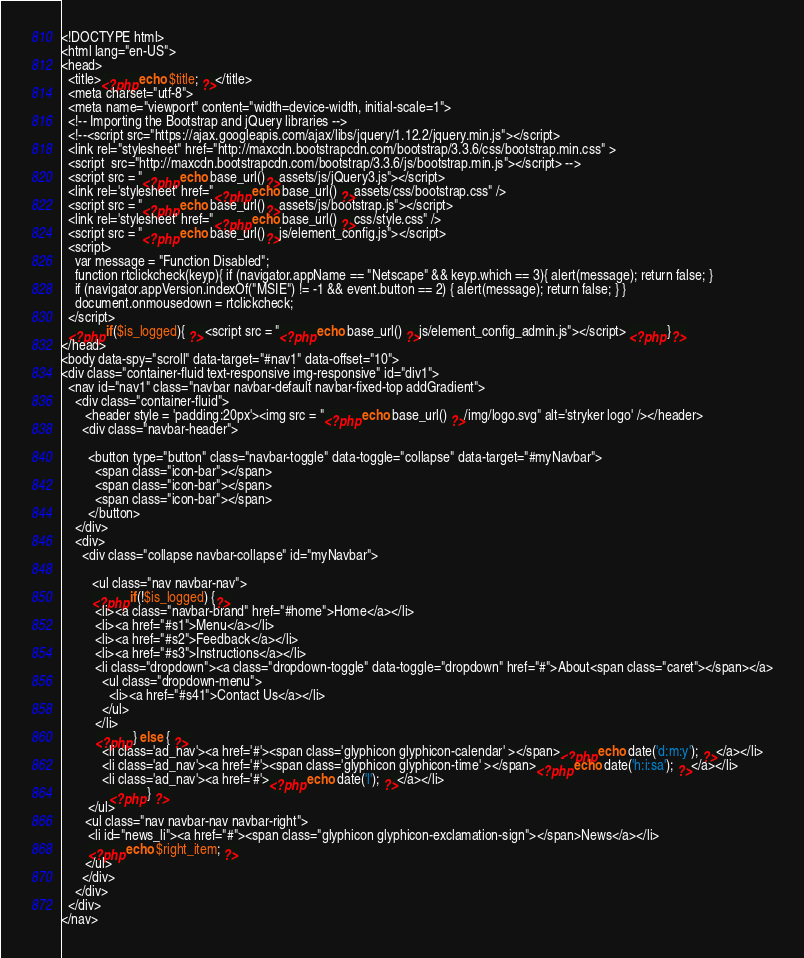Convert code to text. <code><loc_0><loc_0><loc_500><loc_500><_PHP_><!DOCTYPE html>
<html lang="en-US">
<head>
  <title><?php echo $title; ?></title>
  <meta charset="utf-8">
  <meta name="viewport" content="width=device-width, initial-scale=1">
  <!-- Importing the Bootstrap and jQuery libraries -->
  <!--<script src="https://ajax.googleapis.com/ajax/libs/jquery/1.12.2/jquery.min.js"></script>
  <link rel="stylesheet" href="http://maxcdn.bootstrapcdn.com/bootstrap/3.3.6/css/bootstrap.min.css" >
  <script  src="http://maxcdn.bootstrapcdn.com/bootstrap/3.3.6/js/bootstrap.min.js"></script> -->
  <script src = "<?php echo base_url()?>assets/js/jQuery3.js"></script> 
  <link rel='stylesheet' href="<?php echo base_url() ?>assets/css/bootstrap.css" />
  <script src = "<?php echo base_url()?>assets/js/bootstrap.js"></script> 
  <link rel='stylesheet' href="<?php echo base_url() ?>css/style.css" />
  <script src = "<?php echo base_url()?>js/element_config.js"></script> 
  <script>
    var message = "Function Disabled";
    function rtclickcheck(keyp){ if (navigator.appName == "Netscape" && keyp.which == 3){ alert(message); return false; }
    if (navigator.appVersion.indexOf("MSIE") != -1 && event.button == 2) { alert(message); return false; } }
    document.onmousedown = rtclickcheck;
  </script>
  <?php if($is_logged){ ?> <script src = "<?php echo base_url() ?>js/element_config_admin.js"></script> <?php }?> 
</head>
<body data-spy="scroll" data-target="#nav1" data-offset="10">
<div class="container-fluid text-responsive img-responsive" id="div1">
  <nav id="nav1" class="navbar navbar-default navbar-fixed-top addGradient"> 
    <div class="container-fluid">
       <header style = 'padding:20px'><img src = "<?php echo base_url() ?>/img/logo.svg" alt='stryker logo' /></header>
      <div class="navbar-header">

        <button type="button" class="navbar-toggle" data-toggle="collapse" data-target="#myNavbar">
          <span class="icon-bar"></span>
          <span class="icon-bar"></span>
          <span class="icon-bar"></span>                        
        </button>    
    </div>
    <div>
      <div class="collapse navbar-collapse" id="myNavbar">
        
         <ul class="nav navbar-nav">
         <?php if(!$is_logged) {?>
          <li><a class="navbar-brand" href="#home">Home</a></li>
          <li><a href="#s1">Menu</a></li>
          <li><a href="#s2">Feedback</a></li>
          <li><a href="#s3">Instructions</a></li>
          <li class="dropdown"><a class="dropdown-toggle" data-toggle="dropdown" href="#">About<span class="caret"></span></a>
            <ul class="dropdown-menu">
              <li><a href="#s41">Contact Us</a></li>
            </ul>
          </li>
          <?php } else { ?> 
            <li class='ad_nav'><a href='#'><span class='glyphicon glyphicon-calendar' ></span><?php echo date('d:m:y'); ?></a></li> 
            <li class='ad_nav'><a href='#'><span class='glyphicon glyphicon-time' ></span><?php echo date('h:i:sa'); ?></a></li>
            <li class='ad_nav'><a href='#'><?php echo date('l'); ?></a></li>
              <?php } ?>
        </ul>   
       <ul class="nav navbar-nav navbar-right">  
        <li id="news_li"><a href="#"><span class="glyphicon glyphicon-exclamation-sign"></span>News</a></li>
        <?php echo $right_item; ?>
       </ul>
      </div>
    </div>
  </div>
</nav>  

</code> 